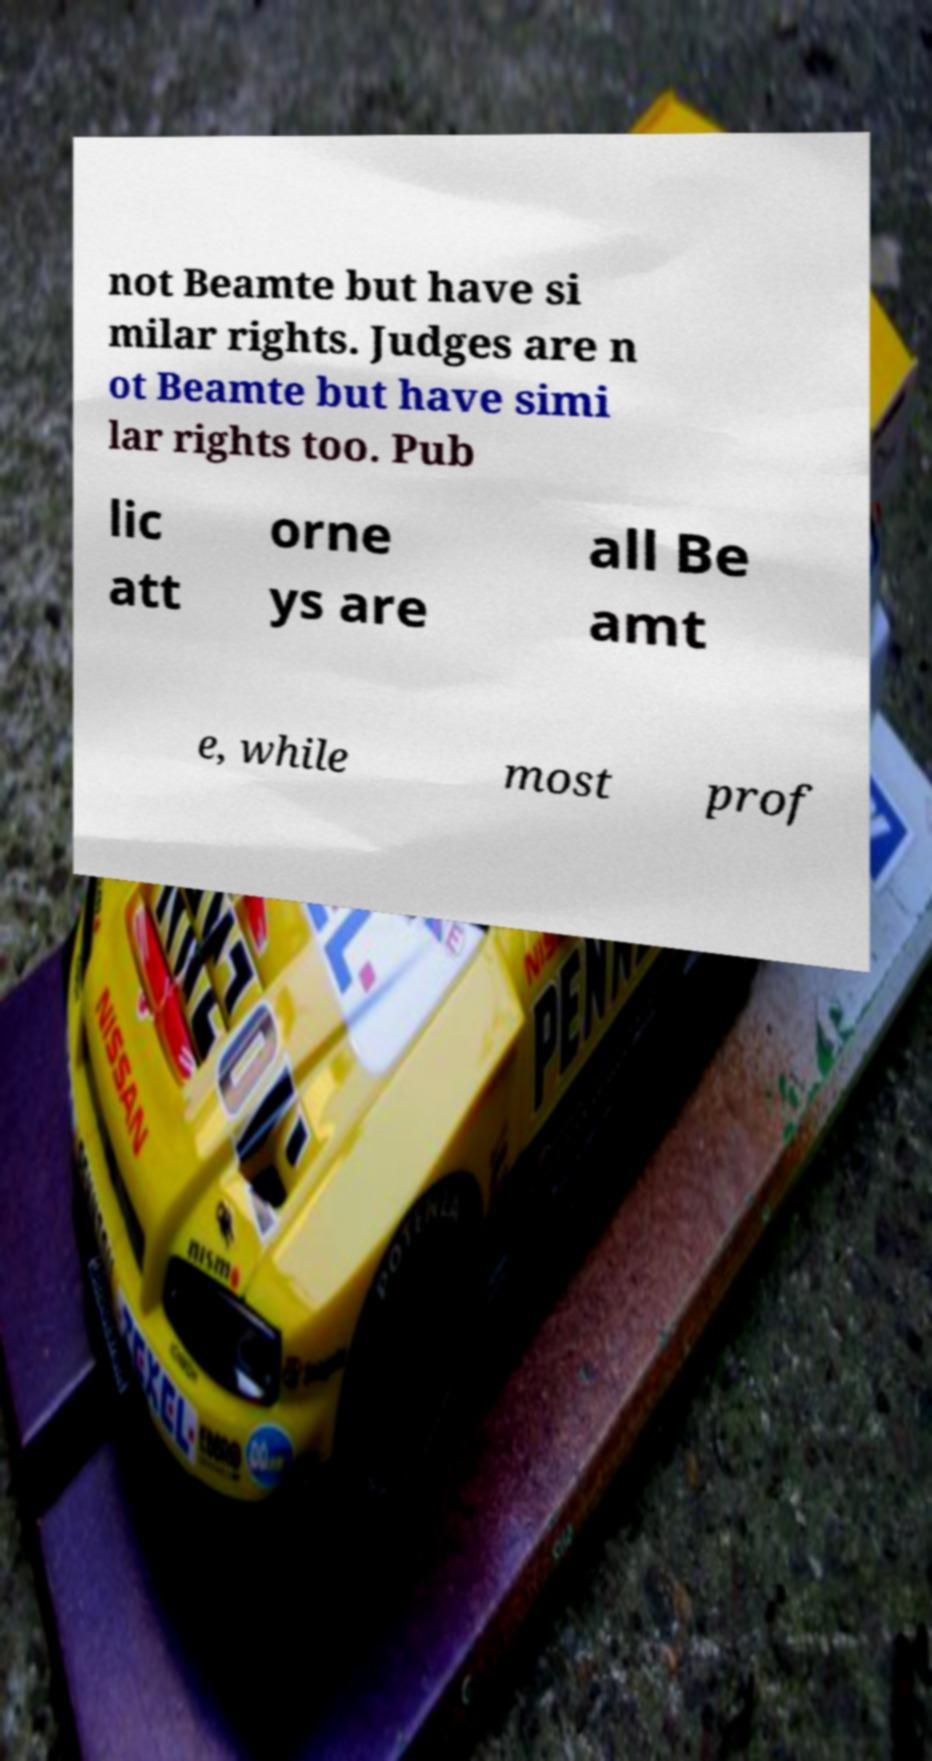There's text embedded in this image that I need extracted. Can you transcribe it verbatim? not Beamte but have si milar rights. Judges are n ot Beamte but have simi lar rights too. Pub lic att orne ys are all Be amt e, while most prof 